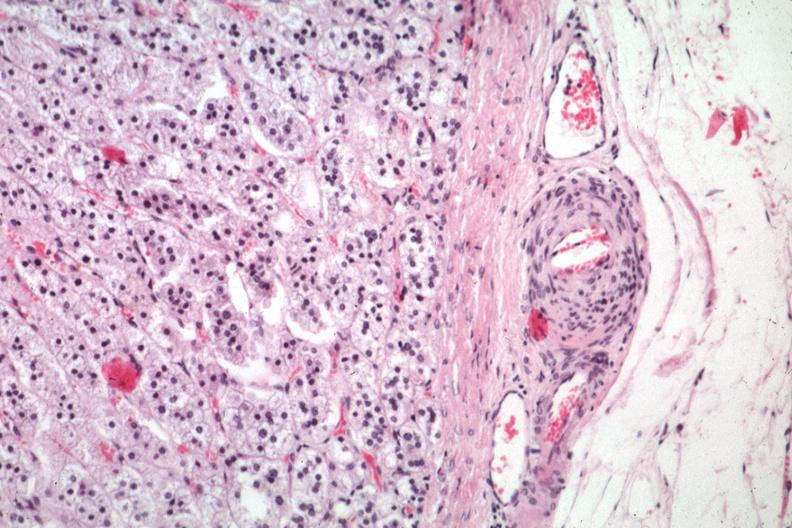what is present?
Answer the question using a single word or phrase. Atheromatous embolus 